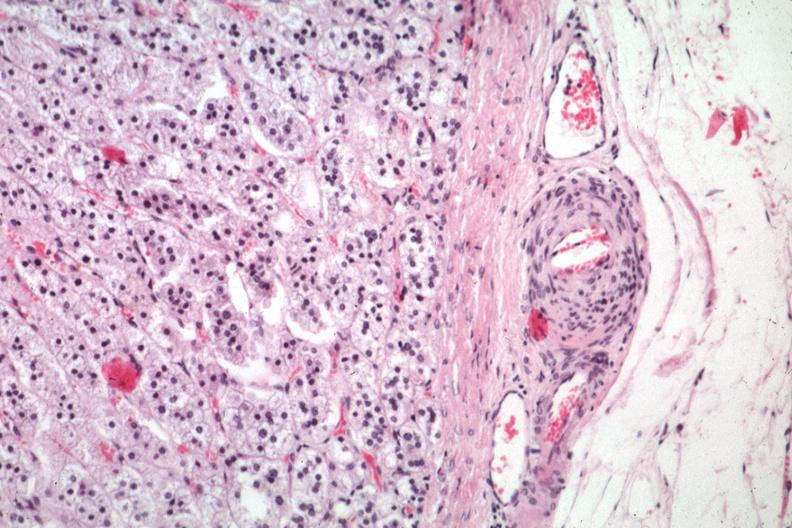what is present?
Answer the question using a single word or phrase. Atheromatous embolus 